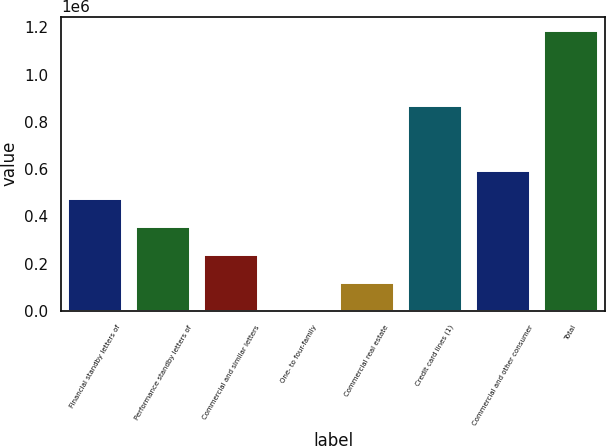<chart> <loc_0><loc_0><loc_500><loc_500><bar_chart><fcel>Financial standby letters of<fcel>Performance standby letters of<fcel>Commercial and similar letters<fcel>One- to four-family<fcel>Commercial real estate<fcel>Credit card lines (1)<fcel>Commercial and other consumer<fcel>Total<nl><fcel>474968<fcel>356383<fcel>237798<fcel>628<fcel>119213<fcel>867261<fcel>593553<fcel>1.18648e+06<nl></chart> 